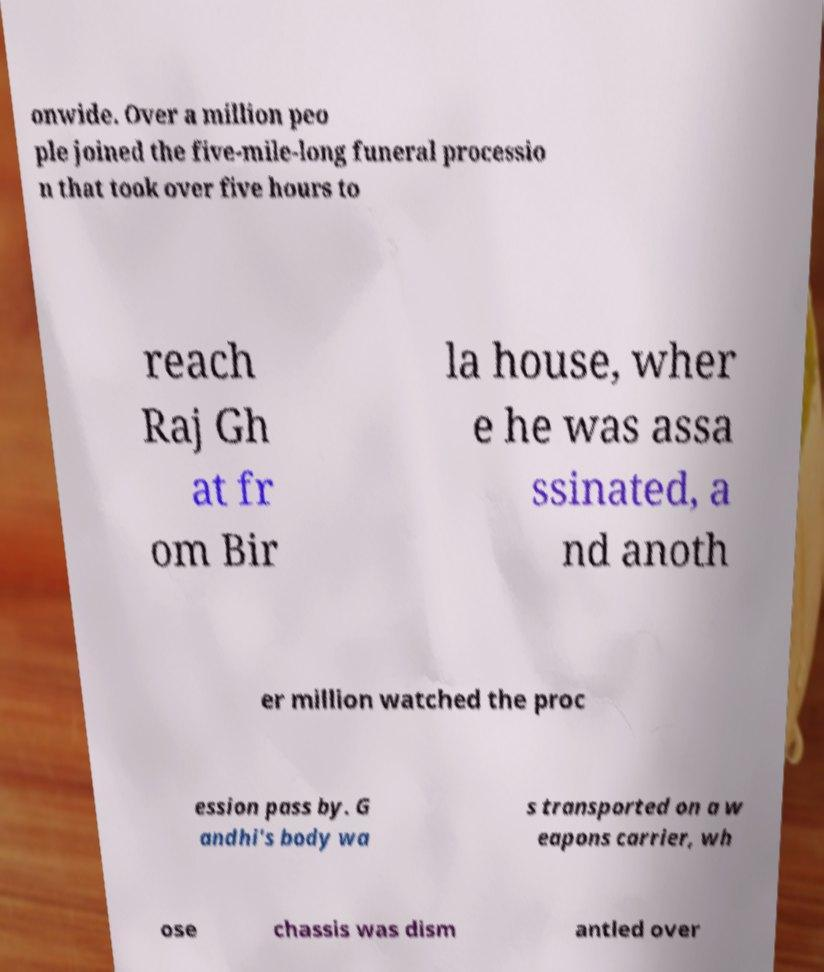Please identify and transcribe the text found in this image. onwide. Over a million peo ple joined the five-mile-long funeral processio n that took over five hours to reach Raj Gh at fr om Bir la house, wher e he was assa ssinated, a nd anoth er million watched the proc ession pass by. G andhi's body wa s transported on a w eapons carrier, wh ose chassis was dism antled over 